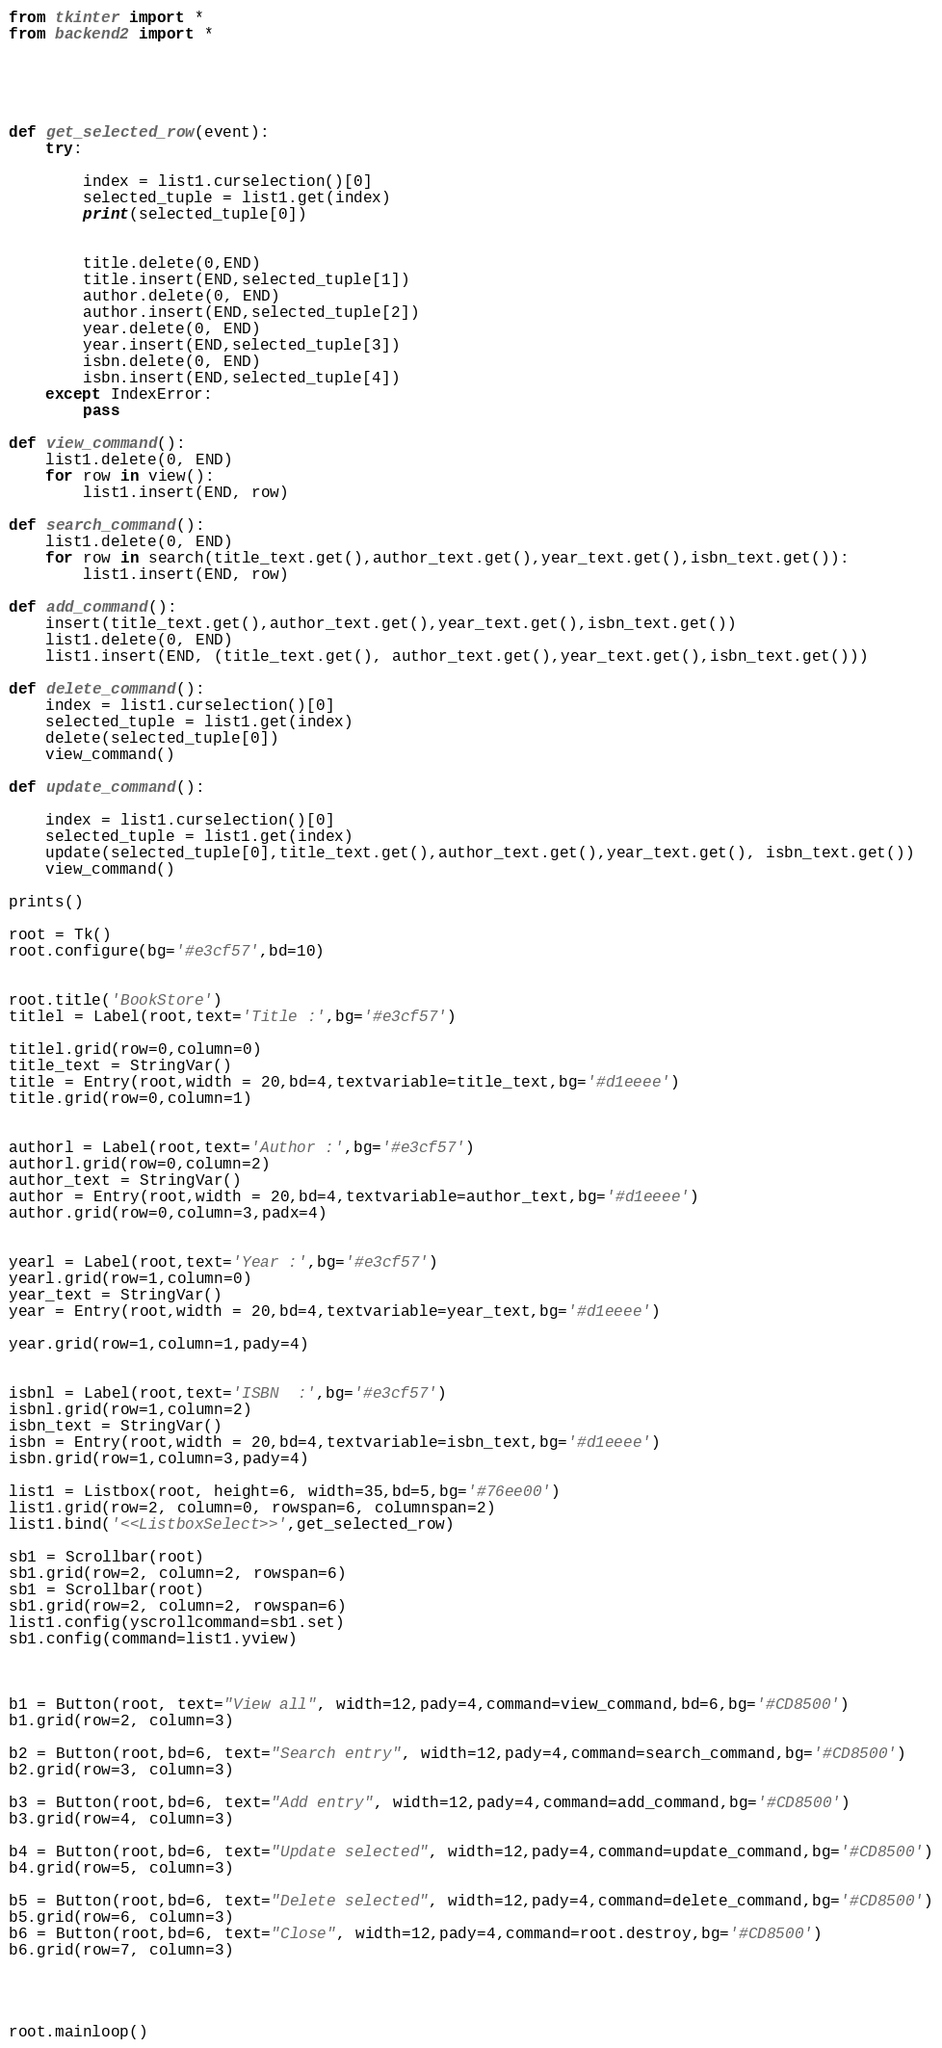<code> <loc_0><loc_0><loc_500><loc_500><_Python_>from tkinter import *
from backend2 import *





def get_selected_row(event):   
    try:
        
        index = list1.curselection()[0]
        selected_tuple = list1.get(index)
        print(selected_tuple[0])

        
        title.delete(0,END)
        title.insert(END,selected_tuple[1])
        author.delete(0, END)
        author.insert(END,selected_tuple[2])
        year.delete(0, END)
        year.insert(END,selected_tuple[3])
        isbn.delete(0, END)
        isbn.insert(END,selected_tuple[4])
    except IndexError:
        pass                

def view_command():
    list1.delete(0, END)  
    for row in view():
        list1.insert(END, row)

def search_command():
    list1.delete(0, END)
    for row in search(title_text.get(),author_text.get(),year_text.get(),isbn_text.get()):
        list1.insert(END, row)

def add_command():
    insert(title_text.get(),author_text.get(),year_text.get(),isbn_text.get())
    list1.delete(0, END)
    list1.insert(END, (title_text.get(), author_text.get(),year_text.get(),isbn_text.get()))

def delete_command():
    index = list1.curselection()[0]
    selected_tuple = list1.get(index)
    delete(selected_tuple[0])
    view_command()

def update_command():
    
    index = list1.curselection()[0]
    selected_tuple = list1.get(index)
    update(selected_tuple[0],title_text.get(),author_text.get(),year_text.get(), isbn_text.get())
    view_command()
    
prints()    

root = Tk()
root.configure(bg='#e3cf57',bd=10)


root.title('BookStore')
titlel = Label(root,text='Title :',bg='#e3cf57')

titlel.grid(row=0,column=0)
title_text = StringVar()
title = Entry(root,width = 20,bd=4,textvariable=title_text,bg='#d1eeee')
title.grid(row=0,column=1)


authorl = Label(root,text='Author :',bg='#e3cf57')
authorl.grid(row=0,column=2)
author_text = StringVar()
author = Entry(root,width = 20,bd=4,textvariable=author_text,bg='#d1eeee')
author.grid(row=0,column=3,padx=4)


yearl = Label(root,text='Year :',bg='#e3cf57')
yearl.grid(row=1,column=0)
year_text = StringVar()
year = Entry(root,width = 20,bd=4,textvariable=year_text,bg='#d1eeee')

year.grid(row=1,column=1,pady=4)


isbnl = Label(root,text='ISBN  :',bg='#e3cf57')
isbnl.grid(row=1,column=2)
isbn_text = StringVar()
isbn = Entry(root,width = 20,bd=4,textvariable=isbn_text,bg='#d1eeee')
isbn.grid(row=1,column=3,pady=4)

list1 = Listbox(root, height=6, width=35,bd=5,bg='#76ee00')
list1.grid(row=2, column=0, rowspan=6, columnspan=2)
list1.bind('<<ListboxSelect>>',get_selected_row)

sb1 = Scrollbar(root)
sb1.grid(row=2, column=2, rowspan=6)
sb1 = Scrollbar(root)
sb1.grid(row=2, column=2, rowspan=6)
list1.config(yscrollcommand=sb1.set)
sb1.config(command=list1.yview)



b1 = Button(root, text="View all", width=12,pady=4,command=view_command,bd=6,bg='#CD8500')
b1.grid(row=2, column=3)

b2 = Button(root,bd=6, text="Search entry", width=12,pady=4,command=search_command,bg='#CD8500')
b2.grid(row=3, column=3)

b3 = Button(root,bd=6, text="Add entry", width=12,pady=4,command=add_command,bg='#CD8500')
b3.grid(row=4, column=3)

b4 = Button(root,bd=6, text="Update selected", width=12,pady=4,command=update_command,bg='#CD8500')
b4.grid(row=5, column=3)

b5 = Button(root,bd=6, text="Delete selected", width=12,pady=4,command=delete_command,bg='#CD8500')
b5.grid(row=6, column=3)
b6 = Button(root,bd=6, text="Close", width=12,pady=4,command=root.destroy,bg='#CD8500')
b6.grid(row=7, column=3)




root.mainloop()


</code> 